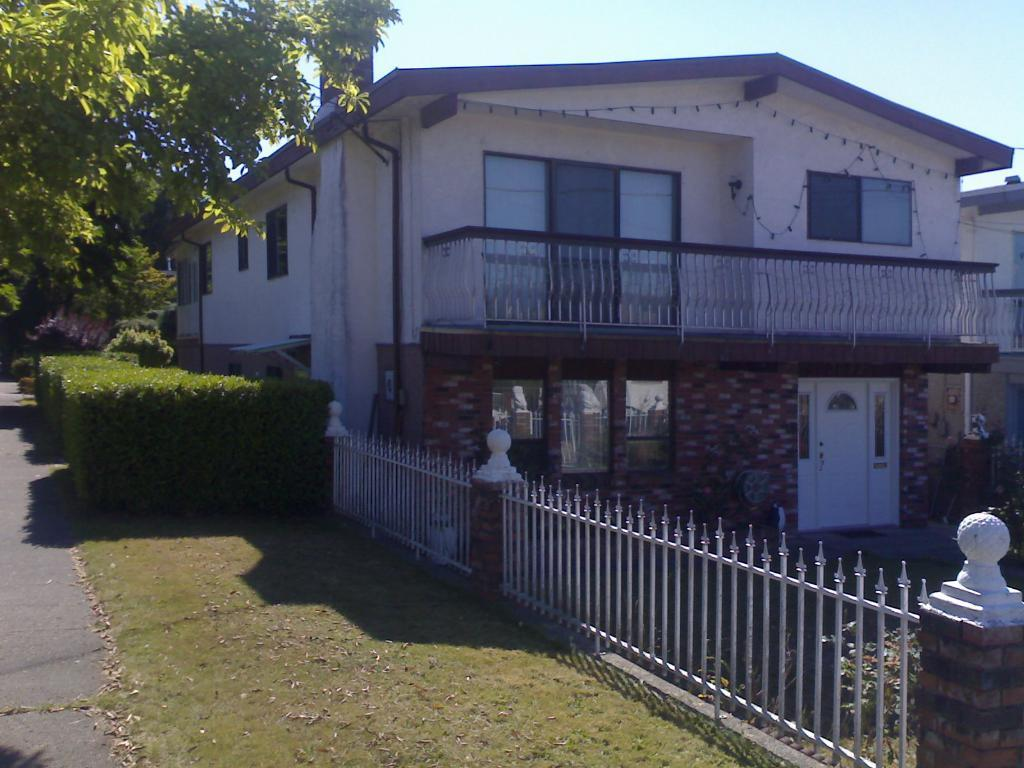What type of structure is present in the image? There is a house in the image. What is located near the house? There is a fence in the image. What type of vegetation can be seen on the left side of the image? Trees and bushes are visible on the left side of the image. What is visible at the top of the image? The sky is visible at the top of the image. How many girls are playing with the star in the image? There are no girls or stars present in the image. 